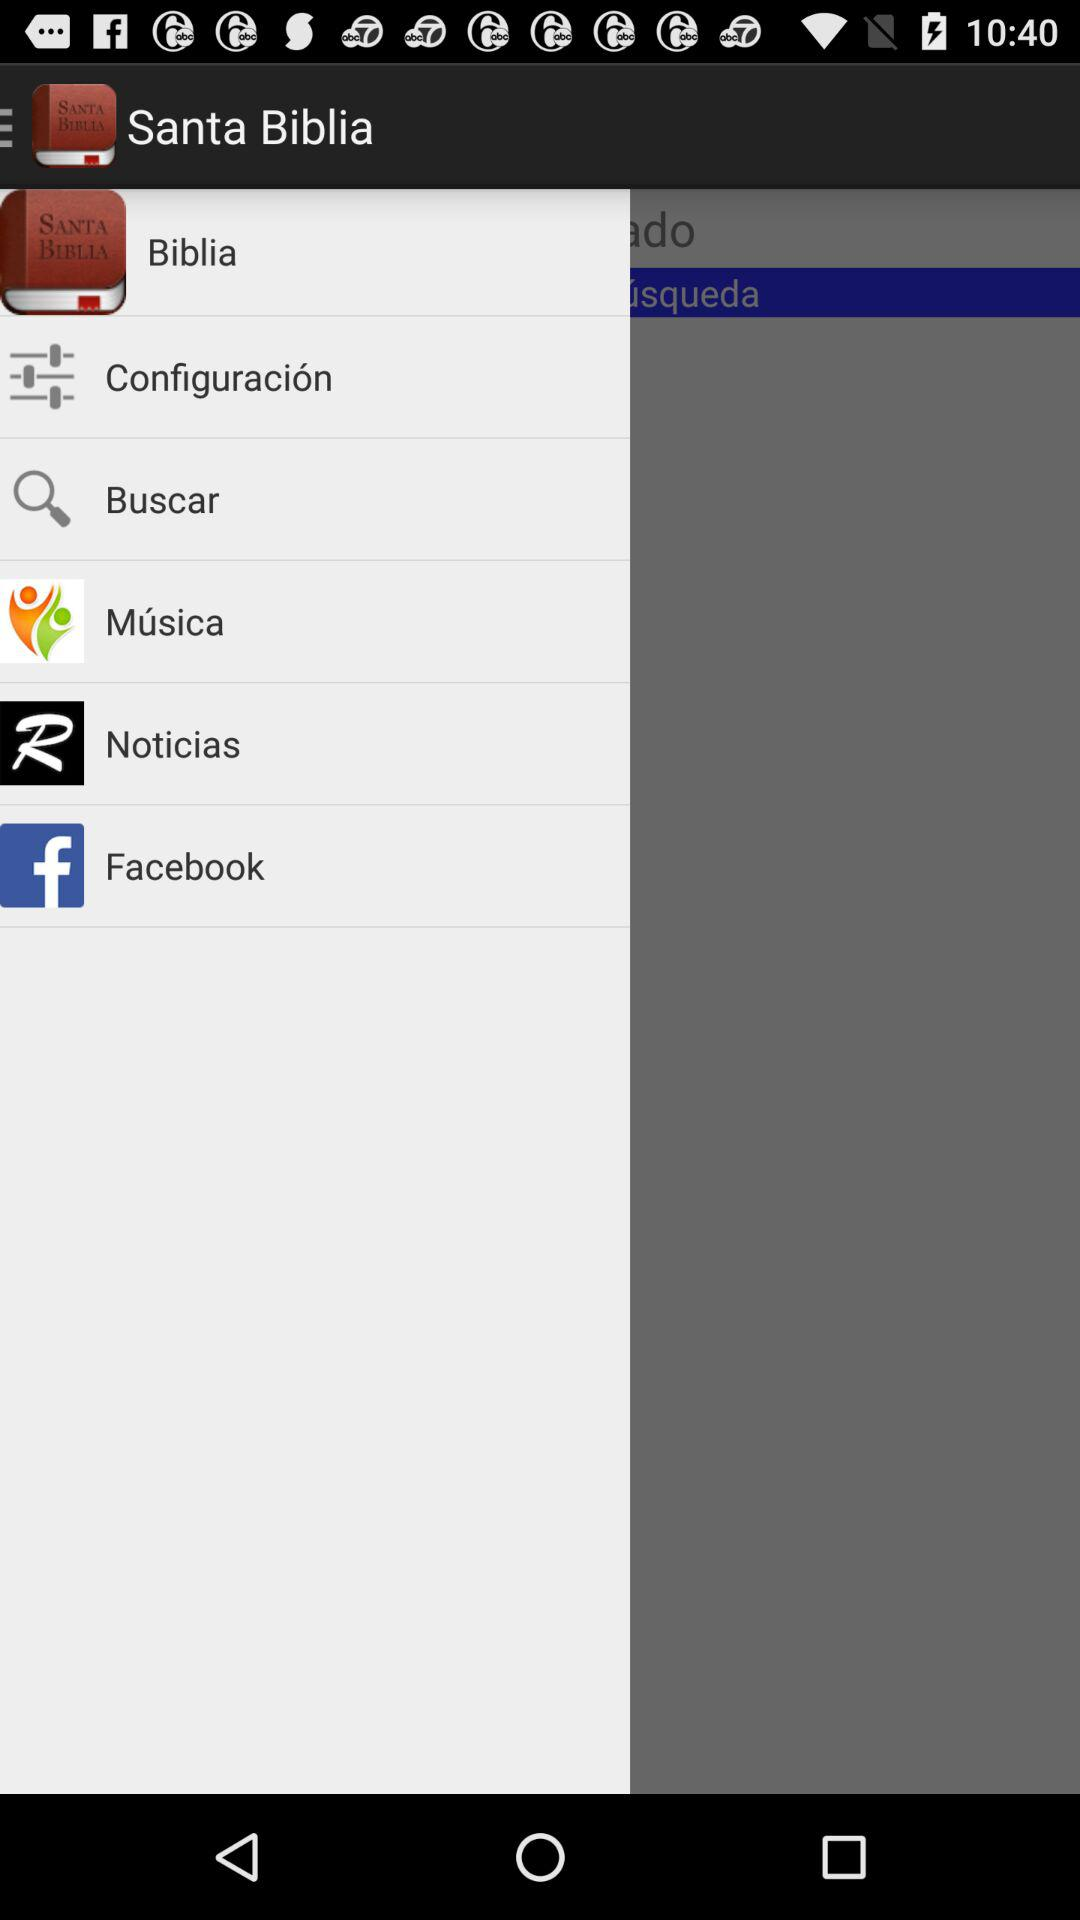What is the application name? The application name is "Santa Biblia". 